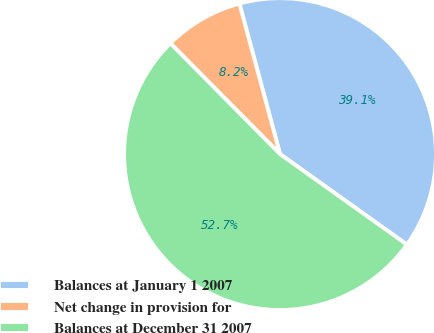Convert chart. <chart><loc_0><loc_0><loc_500><loc_500><pie_chart><fcel>Balances at January 1 2007<fcel>Net change in provision for<fcel>Balances at December 31 2007<nl><fcel>39.06%<fcel>8.22%<fcel>52.72%<nl></chart> 